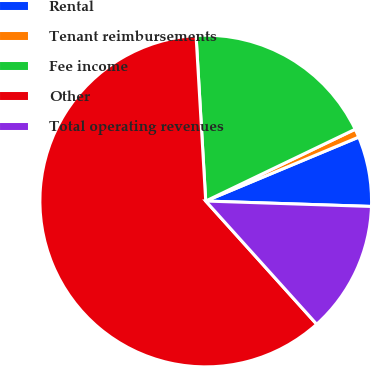Convert chart to OTSL. <chart><loc_0><loc_0><loc_500><loc_500><pie_chart><fcel>Rental<fcel>Tenant reimbursements<fcel>Fee income<fcel>Other<fcel>Total operating revenues<nl><fcel>6.82%<fcel>0.83%<fcel>18.8%<fcel>60.74%<fcel>12.81%<nl></chart> 